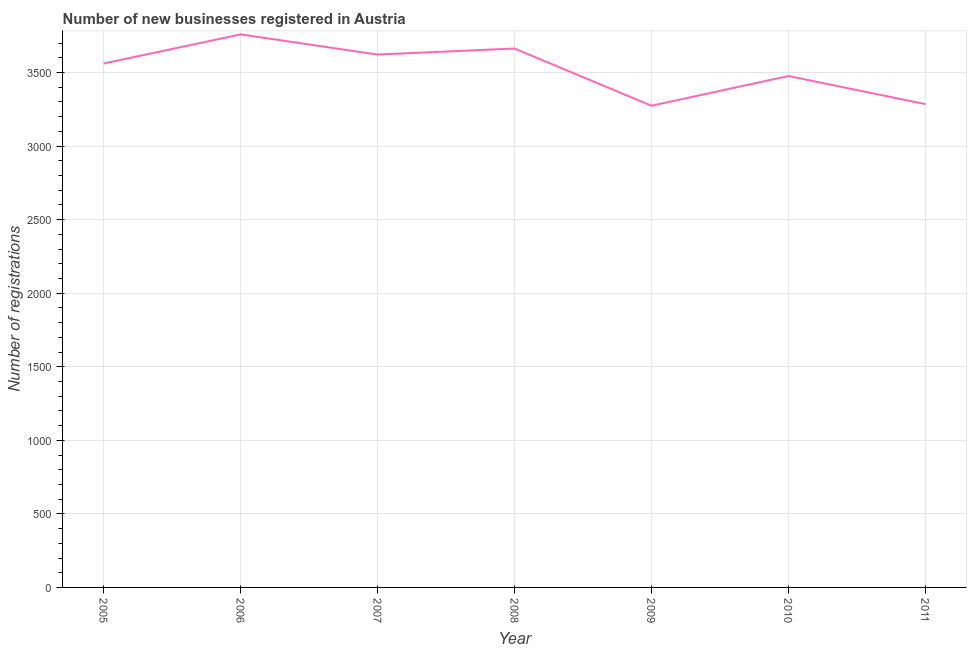What is the number of new business registrations in 2006?
Offer a terse response. 3759. Across all years, what is the maximum number of new business registrations?
Ensure brevity in your answer.  3759. Across all years, what is the minimum number of new business registrations?
Give a very brief answer. 3274. In which year was the number of new business registrations maximum?
Your answer should be compact. 2006. What is the sum of the number of new business registrations?
Your answer should be very brief. 2.46e+04. What is the difference between the number of new business registrations in 2007 and 2011?
Your response must be concise. 337. What is the average number of new business registrations per year?
Offer a very short reply. 3520. What is the median number of new business registrations?
Provide a short and direct response. 3561. Do a majority of the years between 2010 and 2006 (inclusive) have number of new business registrations greater than 1600 ?
Offer a very short reply. Yes. What is the ratio of the number of new business registrations in 2005 to that in 2009?
Your response must be concise. 1.09. Is the number of new business registrations in 2007 less than that in 2010?
Make the answer very short. No. Is the difference between the number of new business registrations in 2008 and 2011 greater than the difference between any two years?
Provide a short and direct response. No. What is the difference between the highest and the second highest number of new business registrations?
Provide a short and direct response. 96. Is the sum of the number of new business registrations in 2007 and 2011 greater than the maximum number of new business registrations across all years?
Give a very brief answer. Yes. What is the difference between the highest and the lowest number of new business registrations?
Keep it short and to the point. 485. In how many years, is the number of new business registrations greater than the average number of new business registrations taken over all years?
Keep it short and to the point. 4. Are the values on the major ticks of Y-axis written in scientific E-notation?
Provide a succinct answer. No. Does the graph contain any zero values?
Keep it short and to the point. No. Does the graph contain grids?
Your answer should be compact. Yes. What is the title of the graph?
Your answer should be compact. Number of new businesses registered in Austria. What is the label or title of the X-axis?
Keep it short and to the point. Year. What is the label or title of the Y-axis?
Your answer should be compact. Number of registrations. What is the Number of registrations in 2005?
Provide a succinct answer. 3561. What is the Number of registrations in 2006?
Provide a short and direct response. 3759. What is the Number of registrations of 2007?
Your answer should be very brief. 3622. What is the Number of registrations in 2008?
Give a very brief answer. 3663. What is the Number of registrations in 2009?
Ensure brevity in your answer.  3274. What is the Number of registrations in 2010?
Keep it short and to the point. 3476. What is the Number of registrations in 2011?
Your response must be concise. 3285. What is the difference between the Number of registrations in 2005 and 2006?
Keep it short and to the point. -198. What is the difference between the Number of registrations in 2005 and 2007?
Your answer should be very brief. -61. What is the difference between the Number of registrations in 2005 and 2008?
Ensure brevity in your answer.  -102. What is the difference between the Number of registrations in 2005 and 2009?
Provide a short and direct response. 287. What is the difference between the Number of registrations in 2005 and 2010?
Provide a short and direct response. 85. What is the difference between the Number of registrations in 2005 and 2011?
Make the answer very short. 276. What is the difference between the Number of registrations in 2006 and 2007?
Ensure brevity in your answer.  137. What is the difference between the Number of registrations in 2006 and 2008?
Keep it short and to the point. 96. What is the difference between the Number of registrations in 2006 and 2009?
Provide a short and direct response. 485. What is the difference between the Number of registrations in 2006 and 2010?
Give a very brief answer. 283. What is the difference between the Number of registrations in 2006 and 2011?
Give a very brief answer. 474. What is the difference between the Number of registrations in 2007 and 2008?
Your response must be concise. -41. What is the difference between the Number of registrations in 2007 and 2009?
Ensure brevity in your answer.  348. What is the difference between the Number of registrations in 2007 and 2010?
Ensure brevity in your answer.  146. What is the difference between the Number of registrations in 2007 and 2011?
Offer a terse response. 337. What is the difference between the Number of registrations in 2008 and 2009?
Make the answer very short. 389. What is the difference between the Number of registrations in 2008 and 2010?
Provide a short and direct response. 187. What is the difference between the Number of registrations in 2008 and 2011?
Keep it short and to the point. 378. What is the difference between the Number of registrations in 2009 and 2010?
Offer a terse response. -202. What is the difference between the Number of registrations in 2009 and 2011?
Your answer should be compact. -11. What is the difference between the Number of registrations in 2010 and 2011?
Provide a short and direct response. 191. What is the ratio of the Number of registrations in 2005 to that in 2006?
Offer a very short reply. 0.95. What is the ratio of the Number of registrations in 2005 to that in 2007?
Give a very brief answer. 0.98. What is the ratio of the Number of registrations in 2005 to that in 2009?
Your response must be concise. 1.09. What is the ratio of the Number of registrations in 2005 to that in 2010?
Offer a terse response. 1.02. What is the ratio of the Number of registrations in 2005 to that in 2011?
Ensure brevity in your answer.  1.08. What is the ratio of the Number of registrations in 2006 to that in 2007?
Make the answer very short. 1.04. What is the ratio of the Number of registrations in 2006 to that in 2008?
Give a very brief answer. 1.03. What is the ratio of the Number of registrations in 2006 to that in 2009?
Offer a terse response. 1.15. What is the ratio of the Number of registrations in 2006 to that in 2010?
Ensure brevity in your answer.  1.08. What is the ratio of the Number of registrations in 2006 to that in 2011?
Ensure brevity in your answer.  1.14. What is the ratio of the Number of registrations in 2007 to that in 2009?
Your response must be concise. 1.11. What is the ratio of the Number of registrations in 2007 to that in 2010?
Offer a very short reply. 1.04. What is the ratio of the Number of registrations in 2007 to that in 2011?
Your answer should be very brief. 1.1. What is the ratio of the Number of registrations in 2008 to that in 2009?
Provide a succinct answer. 1.12. What is the ratio of the Number of registrations in 2008 to that in 2010?
Your answer should be compact. 1.05. What is the ratio of the Number of registrations in 2008 to that in 2011?
Give a very brief answer. 1.11. What is the ratio of the Number of registrations in 2009 to that in 2010?
Offer a very short reply. 0.94. What is the ratio of the Number of registrations in 2009 to that in 2011?
Your response must be concise. 1. What is the ratio of the Number of registrations in 2010 to that in 2011?
Your response must be concise. 1.06. 